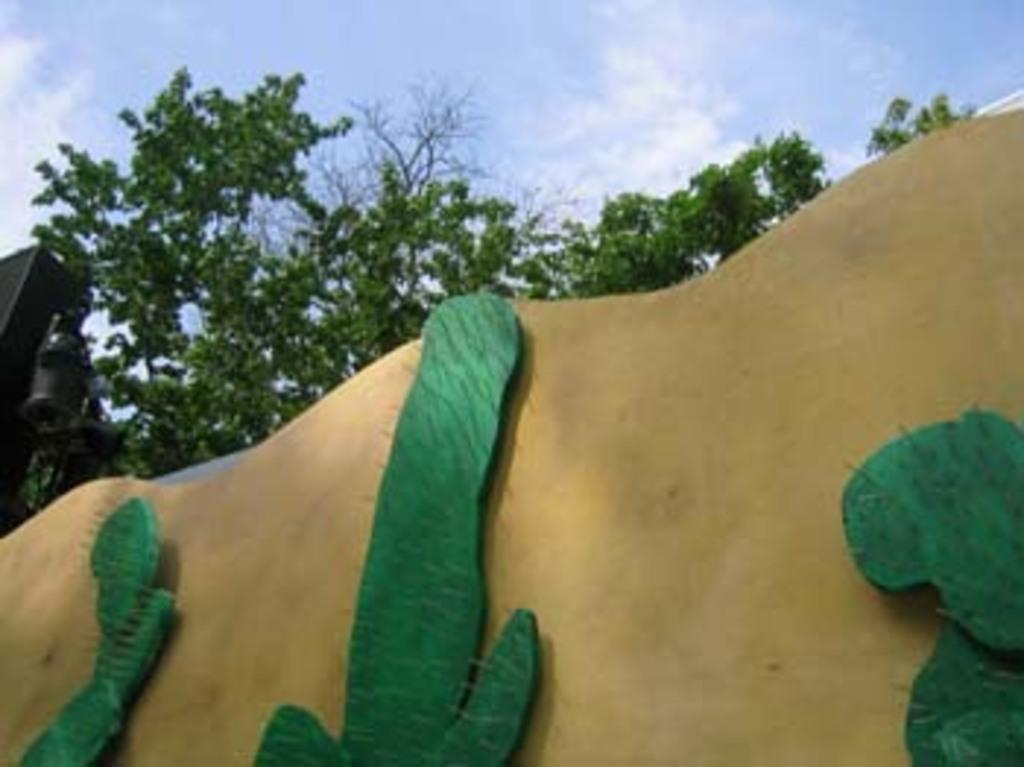What type of structure can be seen in the image? There is a wall in the image. What type of vegetation is present in the image? There are trees in the image. What is visible in the background of the image? The sky is visible in the background of the image. What can be observed in the sky? Clouds are present in the sky. How is the wall being held together with glue and string in the image? There is no mention of glue or string in the image; the wall is a solid structure. What type of assistance is being provided by the trees in the image? The trees are not providing any assistance in the image; they are simply vegetation. 